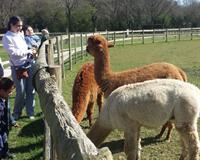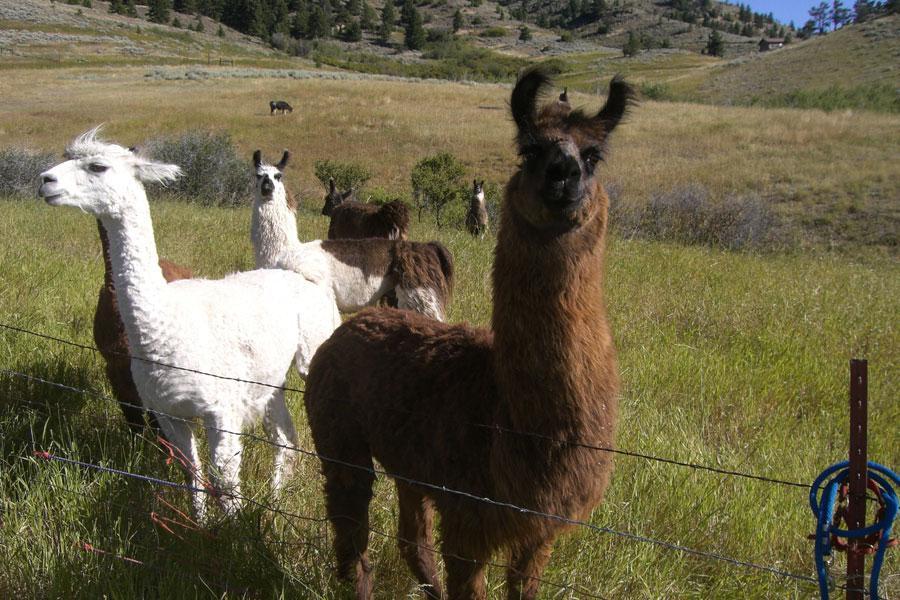The first image is the image on the left, the second image is the image on the right. Assess this claim about the two images: "There are two standing llamas in a field.". Correct or not? Answer yes or no. No. The first image is the image on the left, the second image is the image on the right. Analyze the images presented: Is the assertion "There are three llamas standing in the left image." valid? Answer yes or no. Yes. 